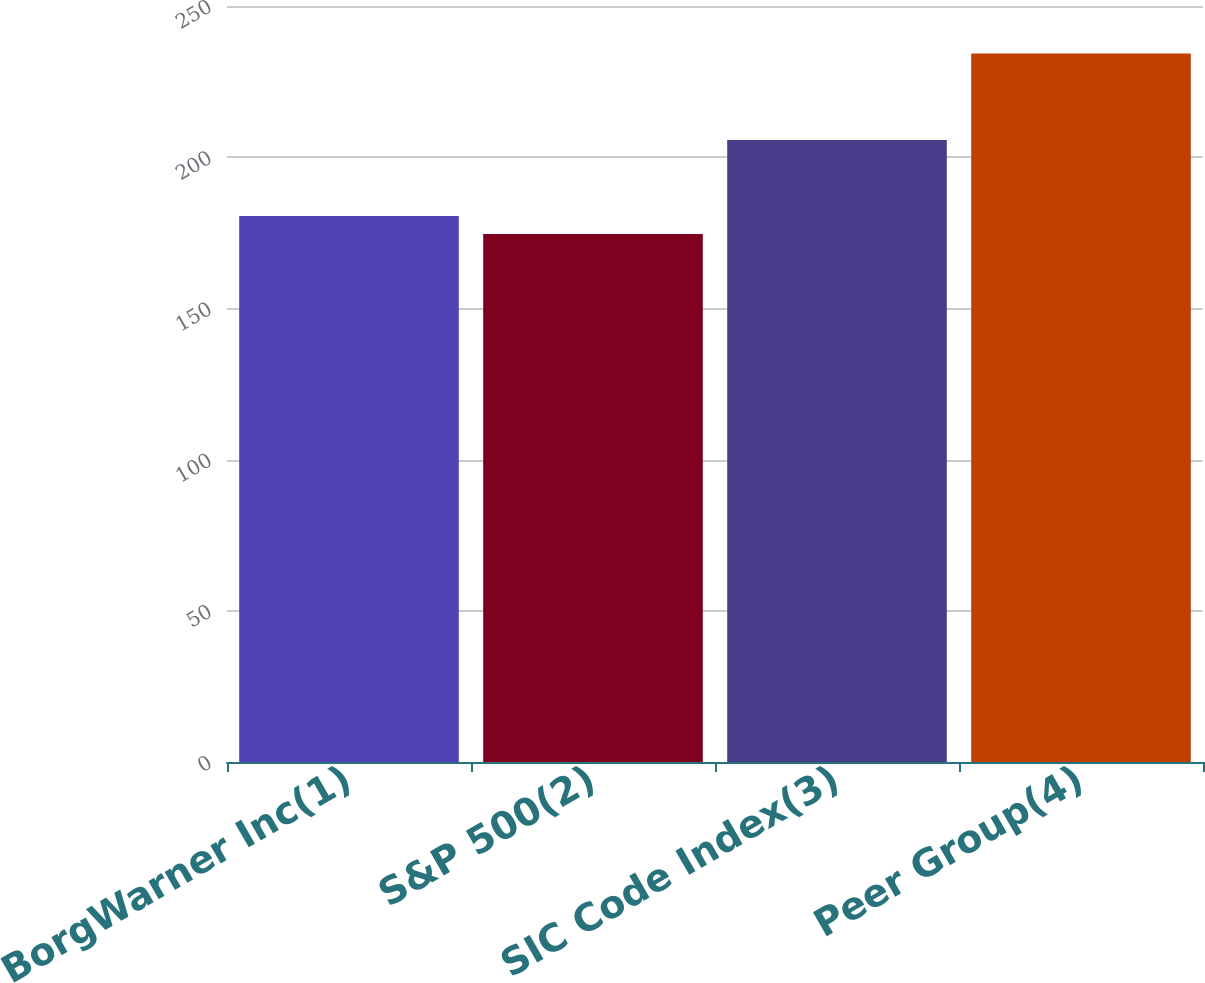Convert chart. <chart><loc_0><loc_0><loc_500><loc_500><bar_chart><fcel>BorgWarner Inc(1)<fcel>S&P 500(2)<fcel>SIC Code Index(3)<fcel>Peer Group(4)<nl><fcel>180.57<fcel>174.6<fcel>205.67<fcel>234.3<nl></chart> 